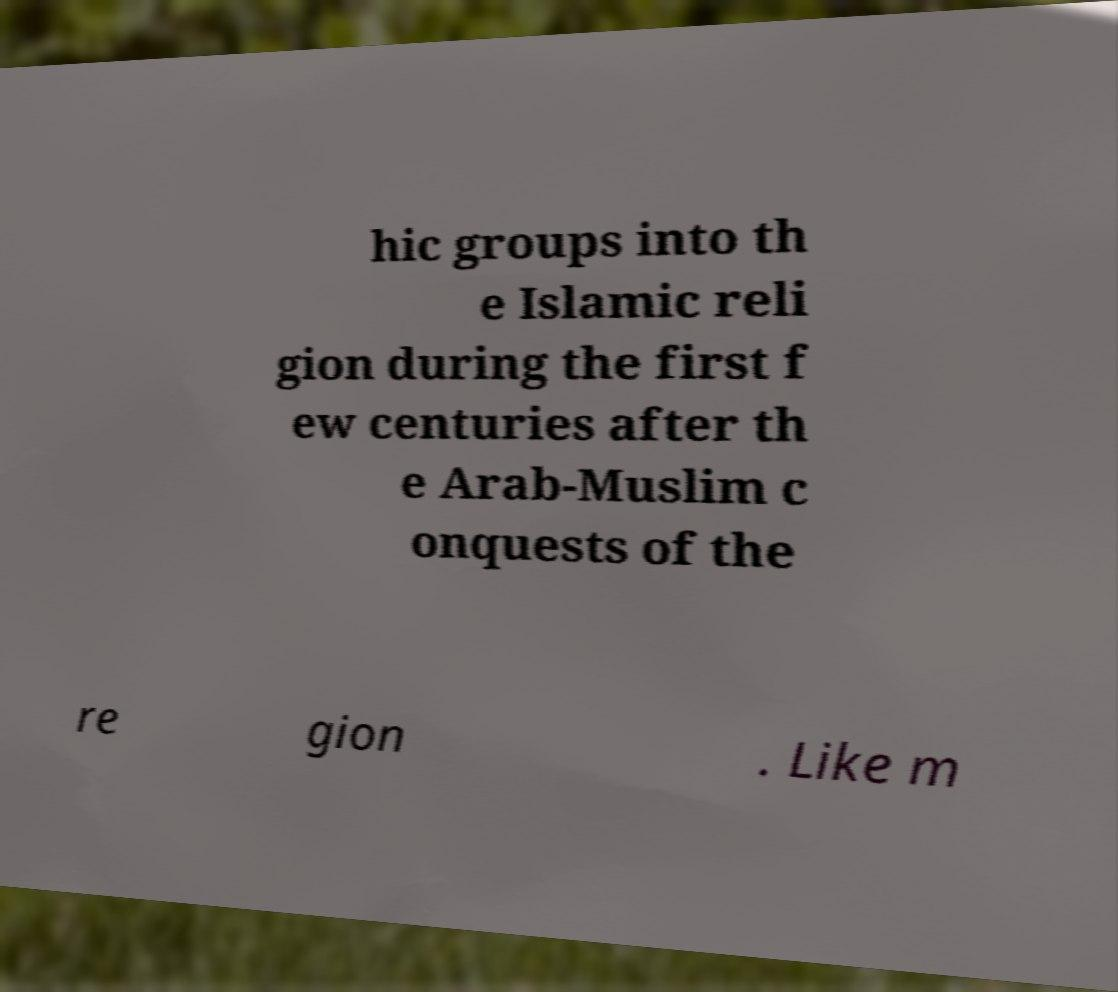Please identify and transcribe the text found in this image. hic groups into th e Islamic reli gion during the first f ew centuries after th e Arab-Muslim c onquests of the re gion . Like m 